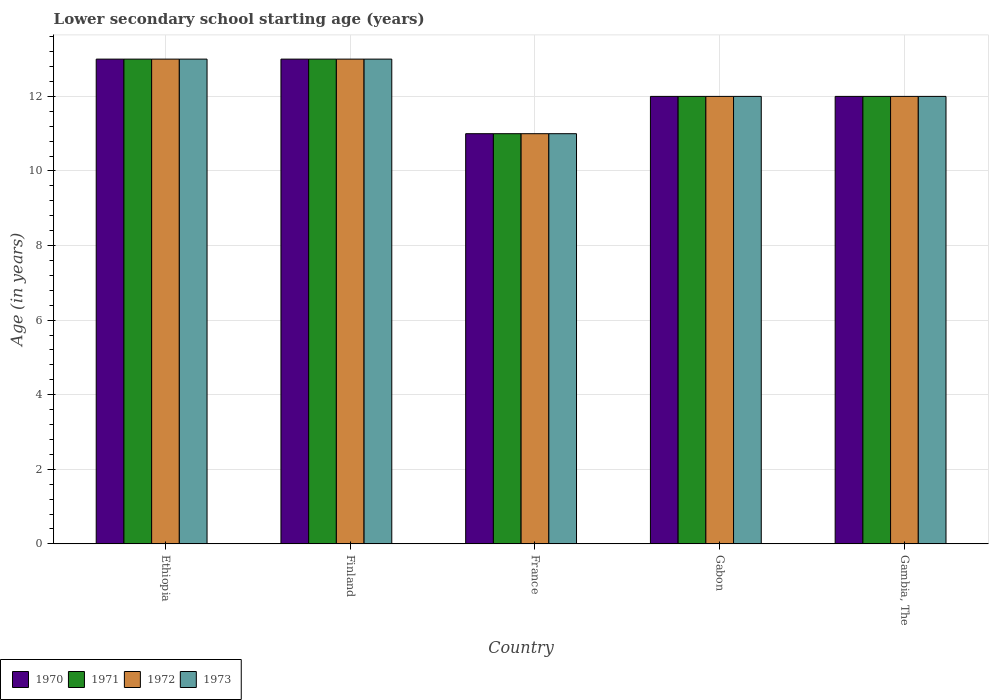How many bars are there on the 5th tick from the left?
Keep it short and to the point. 4. What is the label of the 4th group of bars from the left?
Ensure brevity in your answer.  Gabon. What is the lower secondary school starting age of children in 1971 in Finland?
Give a very brief answer. 13. In which country was the lower secondary school starting age of children in 1970 maximum?
Your answer should be compact. Ethiopia. In which country was the lower secondary school starting age of children in 1973 minimum?
Keep it short and to the point. France. What is the total lower secondary school starting age of children in 1972 in the graph?
Offer a very short reply. 61. What is the difference between the lower secondary school starting age of children of/in 1972 and lower secondary school starting age of children of/in 1970 in Gambia, The?
Your answer should be compact. 0. In how many countries, is the lower secondary school starting age of children in 1970 greater than 3.6 years?
Offer a very short reply. 5. What is the ratio of the lower secondary school starting age of children in 1971 in Ethiopia to that in Finland?
Give a very brief answer. 1. Is the lower secondary school starting age of children in 1972 in Finland less than that in Gabon?
Keep it short and to the point. No. Is the difference between the lower secondary school starting age of children in 1972 in Gabon and Gambia, The greater than the difference between the lower secondary school starting age of children in 1970 in Gabon and Gambia, The?
Your response must be concise. No. What is the difference between the highest and the lowest lower secondary school starting age of children in 1972?
Your answer should be compact. 2. In how many countries, is the lower secondary school starting age of children in 1970 greater than the average lower secondary school starting age of children in 1970 taken over all countries?
Your answer should be compact. 2. What does the 4th bar from the left in Finland represents?
Make the answer very short. 1973. What does the 3rd bar from the right in Gambia, The represents?
Offer a terse response. 1971. Are all the bars in the graph horizontal?
Offer a very short reply. No. What is the difference between two consecutive major ticks on the Y-axis?
Ensure brevity in your answer.  2. Are the values on the major ticks of Y-axis written in scientific E-notation?
Your response must be concise. No. Does the graph contain grids?
Offer a very short reply. Yes. How many legend labels are there?
Your response must be concise. 4. What is the title of the graph?
Keep it short and to the point. Lower secondary school starting age (years). What is the label or title of the X-axis?
Keep it short and to the point. Country. What is the label or title of the Y-axis?
Your answer should be compact. Age (in years). What is the Age (in years) of 1973 in Ethiopia?
Ensure brevity in your answer.  13. What is the Age (in years) of 1971 in Finland?
Provide a succinct answer. 13. What is the Age (in years) of 1973 in Finland?
Make the answer very short. 13. What is the Age (in years) of 1970 in France?
Your answer should be very brief. 11. What is the Age (in years) of 1973 in France?
Offer a very short reply. 11. What is the Age (in years) in 1970 in Gabon?
Offer a terse response. 12. What is the Age (in years) of 1970 in Gambia, The?
Your response must be concise. 12. What is the Age (in years) in 1971 in Gambia, The?
Provide a succinct answer. 12. Across all countries, what is the maximum Age (in years) of 1971?
Your response must be concise. 13. Across all countries, what is the maximum Age (in years) of 1973?
Provide a short and direct response. 13. Across all countries, what is the minimum Age (in years) in 1970?
Offer a very short reply. 11. What is the total Age (in years) of 1973 in the graph?
Your answer should be very brief. 61. What is the difference between the Age (in years) in 1973 in Ethiopia and that in Finland?
Keep it short and to the point. 0. What is the difference between the Age (in years) in 1973 in Ethiopia and that in France?
Your response must be concise. 2. What is the difference between the Age (in years) in 1970 in Ethiopia and that in Gabon?
Your answer should be very brief. 1. What is the difference between the Age (in years) in 1971 in Ethiopia and that in Gabon?
Your answer should be very brief. 1. What is the difference between the Age (in years) of 1972 in Ethiopia and that in Gambia, The?
Ensure brevity in your answer.  1. What is the difference between the Age (in years) of 1970 in Finland and that in France?
Keep it short and to the point. 2. What is the difference between the Age (in years) of 1972 in Finland and that in France?
Your answer should be very brief. 2. What is the difference between the Age (in years) of 1973 in Finland and that in France?
Your answer should be compact. 2. What is the difference between the Age (in years) in 1971 in Finland and that in Gabon?
Offer a very short reply. 1. What is the difference between the Age (in years) in 1971 in Finland and that in Gambia, The?
Your answer should be compact. 1. What is the difference between the Age (in years) in 1972 in Finland and that in Gambia, The?
Make the answer very short. 1. What is the difference between the Age (in years) in 1970 in France and that in Gabon?
Offer a terse response. -1. What is the difference between the Age (in years) in 1971 in France and that in Gabon?
Give a very brief answer. -1. What is the difference between the Age (in years) of 1972 in France and that in Gabon?
Keep it short and to the point. -1. What is the difference between the Age (in years) of 1973 in France and that in Gabon?
Make the answer very short. -1. What is the difference between the Age (in years) of 1971 in France and that in Gambia, The?
Offer a very short reply. -1. What is the difference between the Age (in years) of 1972 in France and that in Gambia, The?
Offer a terse response. -1. What is the difference between the Age (in years) of 1972 in Gabon and that in Gambia, The?
Keep it short and to the point. 0. What is the difference between the Age (in years) of 1971 in Ethiopia and the Age (in years) of 1972 in Finland?
Give a very brief answer. 0. What is the difference between the Age (in years) of 1970 in Ethiopia and the Age (in years) of 1971 in France?
Ensure brevity in your answer.  2. What is the difference between the Age (in years) in 1970 in Ethiopia and the Age (in years) in 1971 in Gabon?
Your answer should be compact. 1. What is the difference between the Age (in years) in 1971 in Ethiopia and the Age (in years) in 1972 in Gabon?
Your answer should be compact. 1. What is the difference between the Age (in years) in 1972 in Ethiopia and the Age (in years) in 1973 in Gabon?
Keep it short and to the point. 1. What is the difference between the Age (in years) of 1970 in Ethiopia and the Age (in years) of 1971 in Gambia, The?
Keep it short and to the point. 1. What is the difference between the Age (in years) of 1970 in Ethiopia and the Age (in years) of 1972 in Gambia, The?
Your answer should be very brief. 1. What is the difference between the Age (in years) of 1970 in Ethiopia and the Age (in years) of 1973 in Gambia, The?
Make the answer very short. 1. What is the difference between the Age (in years) in 1971 in Ethiopia and the Age (in years) in 1972 in Gambia, The?
Provide a succinct answer. 1. What is the difference between the Age (in years) in 1970 in Finland and the Age (in years) in 1971 in France?
Make the answer very short. 2. What is the difference between the Age (in years) of 1970 in Finland and the Age (in years) of 1972 in France?
Offer a terse response. 2. What is the difference between the Age (in years) in 1972 in Finland and the Age (in years) in 1973 in France?
Offer a very short reply. 2. What is the difference between the Age (in years) of 1970 in Finland and the Age (in years) of 1973 in Gabon?
Your answer should be very brief. 1. What is the difference between the Age (in years) in 1971 in Finland and the Age (in years) in 1973 in Gabon?
Ensure brevity in your answer.  1. What is the difference between the Age (in years) of 1970 in Finland and the Age (in years) of 1971 in Gambia, The?
Offer a terse response. 1. What is the difference between the Age (in years) in 1971 in Finland and the Age (in years) in 1972 in Gambia, The?
Keep it short and to the point. 1. What is the difference between the Age (in years) in 1971 in Finland and the Age (in years) in 1973 in Gambia, The?
Your response must be concise. 1. What is the difference between the Age (in years) in 1972 in Finland and the Age (in years) in 1973 in Gambia, The?
Your answer should be very brief. 1. What is the difference between the Age (in years) of 1970 in France and the Age (in years) of 1973 in Gabon?
Make the answer very short. -1. What is the difference between the Age (in years) in 1971 in France and the Age (in years) in 1972 in Gabon?
Your response must be concise. -1. What is the difference between the Age (in years) in 1970 in France and the Age (in years) in 1971 in Gambia, The?
Provide a succinct answer. -1. What is the difference between the Age (in years) in 1970 in France and the Age (in years) in 1972 in Gambia, The?
Keep it short and to the point. -1. What is the difference between the Age (in years) in 1971 in France and the Age (in years) in 1972 in Gambia, The?
Ensure brevity in your answer.  -1. What is the difference between the Age (in years) of 1970 in Gabon and the Age (in years) of 1973 in Gambia, The?
Provide a short and direct response. 0. What is the difference between the Age (in years) of 1971 in Gabon and the Age (in years) of 1973 in Gambia, The?
Your response must be concise. 0. What is the difference between the Age (in years) of 1972 in Gabon and the Age (in years) of 1973 in Gambia, The?
Give a very brief answer. 0. What is the average Age (in years) in 1970 per country?
Offer a terse response. 12.2. What is the average Age (in years) in 1971 per country?
Your answer should be very brief. 12.2. What is the difference between the Age (in years) in 1970 and Age (in years) in 1971 in Ethiopia?
Provide a succinct answer. 0. What is the difference between the Age (in years) in 1971 and Age (in years) in 1972 in Ethiopia?
Provide a short and direct response. 0. What is the difference between the Age (in years) in 1971 and Age (in years) in 1973 in Ethiopia?
Your answer should be very brief. 0. What is the difference between the Age (in years) of 1972 and Age (in years) of 1973 in Ethiopia?
Provide a short and direct response. 0. What is the difference between the Age (in years) of 1970 and Age (in years) of 1971 in Finland?
Offer a terse response. 0. What is the difference between the Age (in years) of 1970 and Age (in years) of 1972 in Finland?
Provide a succinct answer. 0. What is the difference between the Age (in years) in 1971 and Age (in years) in 1972 in Finland?
Make the answer very short. 0. What is the difference between the Age (in years) of 1971 and Age (in years) of 1973 in Finland?
Keep it short and to the point. 0. What is the difference between the Age (in years) in 1972 and Age (in years) in 1973 in Finland?
Make the answer very short. 0. What is the difference between the Age (in years) in 1971 and Age (in years) in 1973 in France?
Ensure brevity in your answer.  0. What is the difference between the Age (in years) of 1972 and Age (in years) of 1973 in France?
Keep it short and to the point. 0. What is the difference between the Age (in years) of 1970 and Age (in years) of 1971 in Gabon?
Provide a short and direct response. 0. What is the difference between the Age (in years) in 1970 and Age (in years) in 1972 in Gabon?
Offer a terse response. 0. What is the difference between the Age (in years) of 1971 and Age (in years) of 1972 in Gabon?
Make the answer very short. 0. What is the difference between the Age (in years) of 1971 and Age (in years) of 1973 in Gabon?
Provide a succinct answer. 0. What is the difference between the Age (in years) in 1970 and Age (in years) in 1971 in Gambia, The?
Keep it short and to the point. 0. What is the difference between the Age (in years) of 1970 and Age (in years) of 1972 in Gambia, The?
Provide a short and direct response. 0. What is the difference between the Age (in years) in 1970 and Age (in years) in 1973 in Gambia, The?
Keep it short and to the point. 0. What is the difference between the Age (in years) in 1971 and Age (in years) in 1972 in Gambia, The?
Offer a very short reply. 0. What is the difference between the Age (in years) in 1971 and Age (in years) in 1973 in Gambia, The?
Your response must be concise. 0. What is the ratio of the Age (in years) in 1972 in Ethiopia to that in Finland?
Give a very brief answer. 1. What is the ratio of the Age (in years) in 1970 in Ethiopia to that in France?
Make the answer very short. 1.18. What is the ratio of the Age (in years) of 1971 in Ethiopia to that in France?
Provide a succinct answer. 1.18. What is the ratio of the Age (in years) of 1972 in Ethiopia to that in France?
Offer a very short reply. 1.18. What is the ratio of the Age (in years) of 1973 in Ethiopia to that in France?
Offer a terse response. 1.18. What is the ratio of the Age (in years) in 1971 in Ethiopia to that in Gabon?
Your answer should be compact. 1.08. What is the ratio of the Age (in years) of 1972 in Ethiopia to that in Gabon?
Provide a succinct answer. 1.08. What is the ratio of the Age (in years) in 1970 in Ethiopia to that in Gambia, The?
Offer a terse response. 1.08. What is the ratio of the Age (in years) of 1973 in Ethiopia to that in Gambia, The?
Provide a short and direct response. 1.08. What is the ratio of the Age (in years) in 1970 in Finland to that in France?
Provide a short and direct response. 1.18. What is the ratio of the Age (in years) of 1971 in Finland to that in France?
Your response must be concise. 1.18. What is the ratio of the Age (in years) of 1972 in Finland to that in France?
Offer a terse response. 1.18. What is the ratio of the Age (in years) in 1973 in Finland to that in France?
Offer a very short reply. 1.18. What is the ratio of the Age (in years) in 1970 in Finland to that in Gabon?
Your response must be concise. 1.08. What is the ratio of the Age (in years) in 1971 in Finland to that in Gabon?
Offer a terse response. 1.08. What is the ratio of the Age (in years) in 1970 in Finland to that in Gambia, The?
Your answer should be compact. 1.08. What is the ratio of the Age (in years) of 1972 in Finland to that in Gambia, The?
Your response must be concise. 1.08. What is the ratio of the Age (in years) of 1973 in Finland to that in Gambia, The?
Offer a terse response. 1.08. What is the ratio of the Age (in years) in 1971 in France to that in Gabon?
Offer a very short reply. 0.92. What is the ratio of the Age (in years) in 1973 in France to that in Gabon?
Provide a short and direct response. 0.92. What is the ratio of the Age (in years) in 1972 in France to that in Gambia, The?
Your answer should be very brief. 0.92. What is the ratio of the Age (in years) of 1972 in Gabon to that in Gambia, The?
Provide a succinct answer. 1. What is the ratio of the Age (in years) of 1973 in Gabon to that in Gambia, The?
Your response must be concise. 1. What is the difference between the highest and the second highest Age (in years) in 1972?
Make the answer very short. 0. What is the difference between the highest and the lowest Age (in years) in 1973?
Your answer should be compact. 2. 